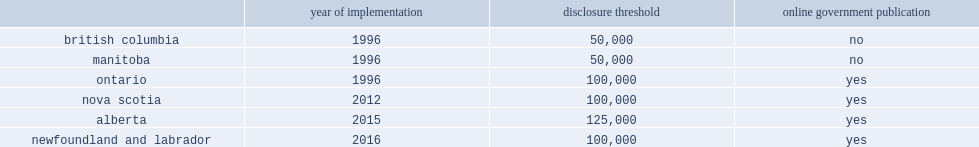What was the disclosure threshold (dollars) in alberta? 125000.0. 